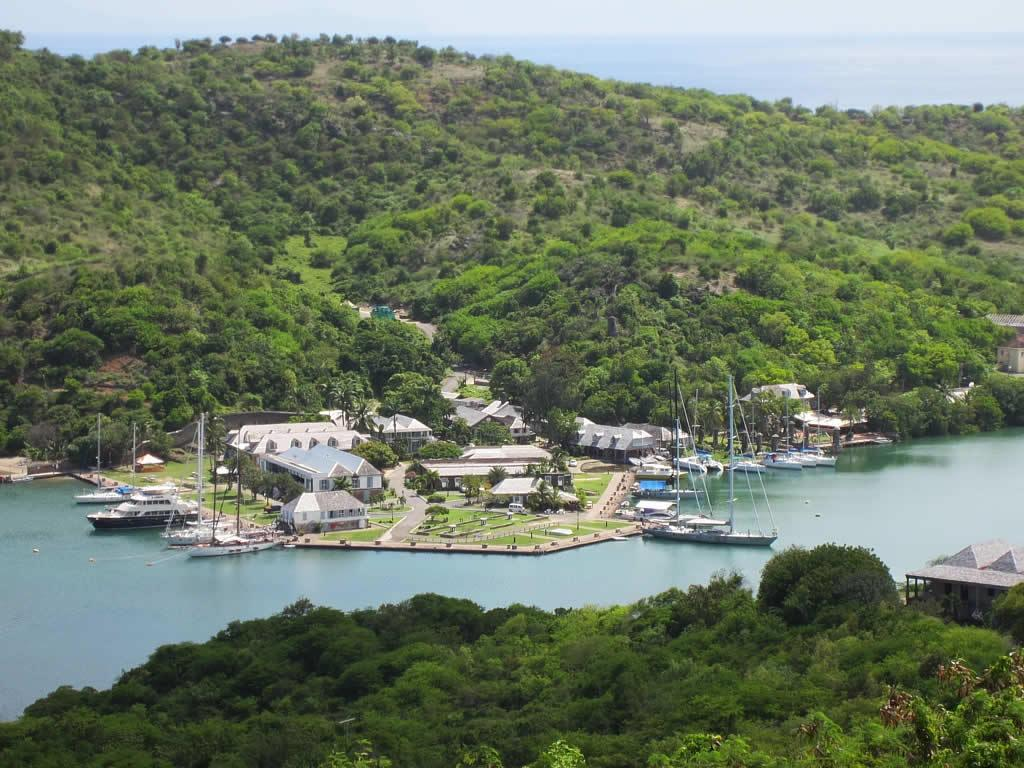What type of natural landscape is depicted in the image? The image contains mountains covered with plants and trees. What can be seen in the middle of the image? There is water in the middle of the image. Are there any human-made structures near the water? Yes, there are houses along the water. What type of transportation is present in the water? Boats are present in the water. What kind of vegetation is located at the bottom of the image? Big trees are located at the bottom of the image. What is the detail of the frog's skin in the image? There is no frog present in the image, so it is not possible to describe the detail of its skin. 